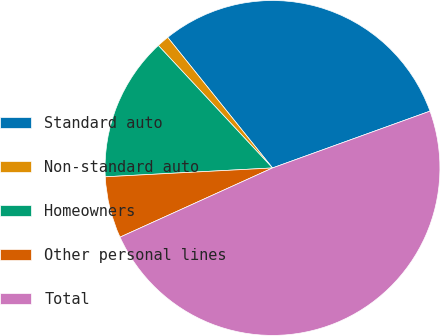<chart> <loc_0><loc_0><loc_500><loc_500><pie_chart><fcel>Standard auto<fcel>Non-standard auto<fcel>Homeowners<fcel>Other personal lines<fcel>Total<nl><fcel>30.25%<fcel>1.18%<fcel>13.9%<fcel>5.94%<fcel>48.73%<nl></chart> 